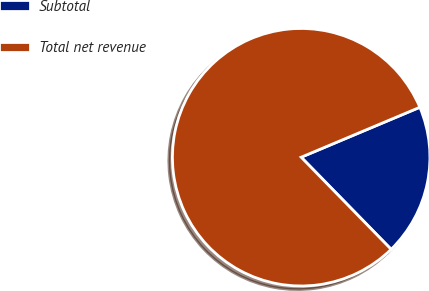Convert chart. <chart><loc_0><loc_0><loc_500><loc_500><pie_chart><fcel>Subtotal<fcel>Total net revenue<nl><fcel>19.03%<fcel>80.97%<nl></chart> 